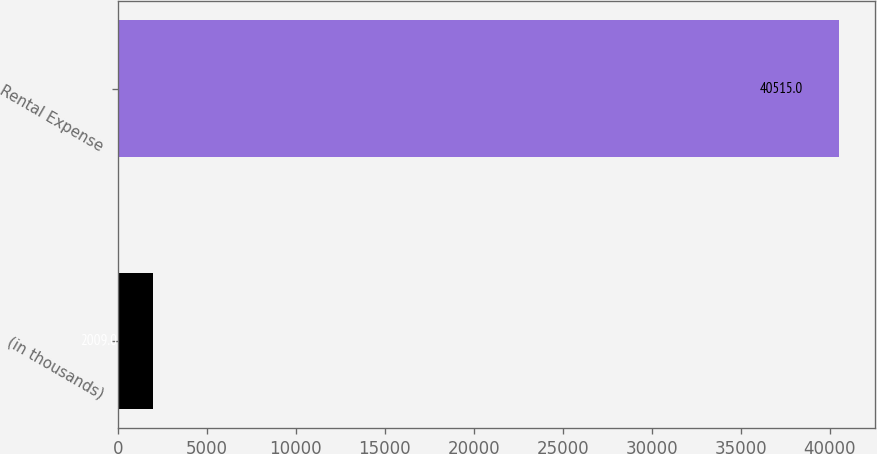<chart> <loc_0><loc_0><loc_500><loc_500><bar_chart><fcel>(in thousands)<fcel>Rental Expense<nl><fcel>2009<fcel>40515<nl></chart> 